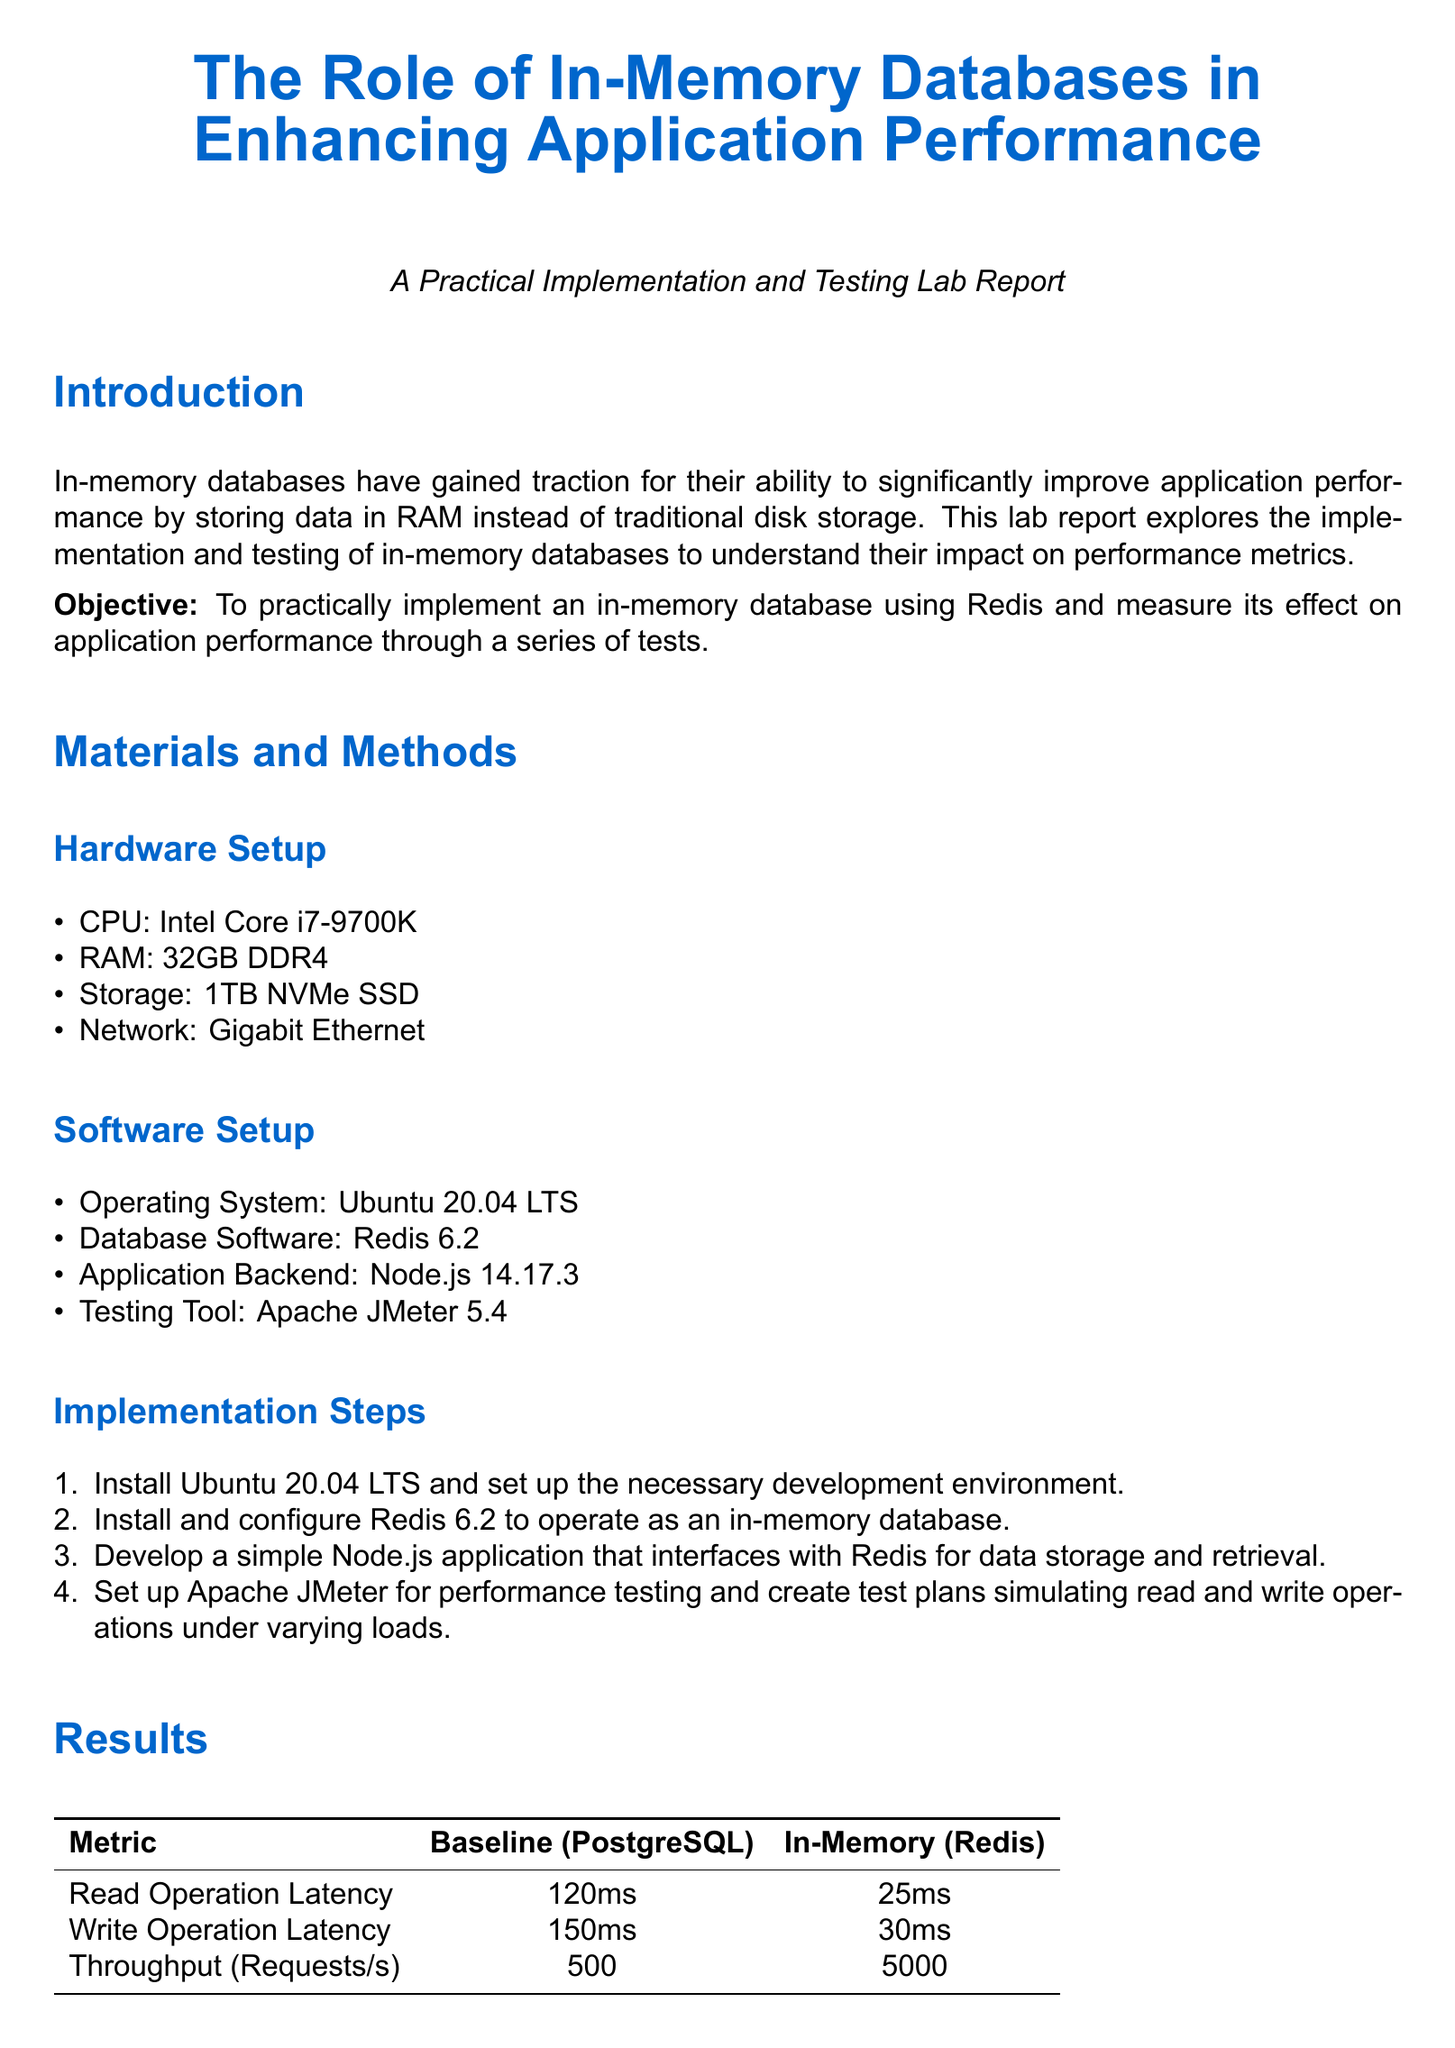What is the CPU model used in the hardware setup? The document states that the CPU model used in the hardware setup is Intel Core i7-9700K.
Answer: Intel Core i7-9700K What is the RAM size listed in the document? The report specifies that the RAM size utilized in the hardware setup is 32GB DDR4.
Answer: 32GB DDR4 What is the latency for write operations in the In-Memory (Redis) section? According to the results, the write operation latency for Redis is compared to PostgreSQL, showing a latency of 30 milliseconds for Redis.
Answer: 30ms How much throughput did the In-Memory (Redis) achieve in requests per second? The results indicate that Redis achieved a throughput of 5000 requests per second, which is significantly higher than PostgreSQL.
Answer: 5000 What software was used for performance testing in the lab report? The document mentions that Apache JMeter 5.4 was used as the testing tool for performance testing.
Answer: Apache JMeter 5.4 What is the objective of this lab report? The document states that the objective is to practically implement an in-memory database using Redis and measure its effect on application performance through a series of tests.
Answer: To practically implement an in-memory database using Redis and measure performance effects What future work does the report suggest? The report indicates that future work should explore hybrid database architectures and different in-memory database technologies' impact on performance.
Answer: Explore hybrid database architectures and different in-memory database technologies Which database was used as a baseline for comparison in the testing? The document specifically mentions PostgreSQL as the baseline for performance comparison in the results section.
Answer: PostgreSQL 